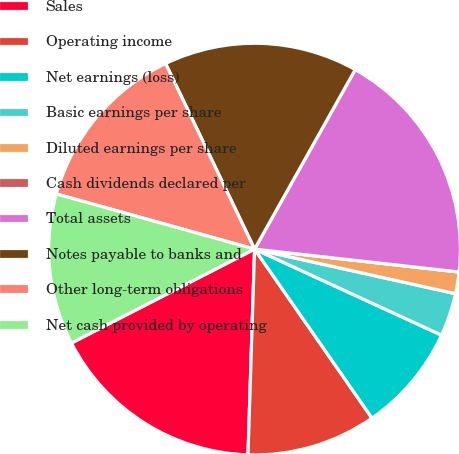<chart> <loc_0><loc_0><loc_500><loc_500><pie_chart><fcel>Sales<fcel>Operating income<fcel>Net earnings (loss)<fcel>Basic earnings per share<fcel>Diluted earnings per share<fcel>Cash dividends declared per<fcel>Total assets<fcel>Notes payable to banks and<fcel>Other long-term obligations<fcel>Net cash provided by operating<nl><fcel>16.95%<fcel>10.17%<fcel>8.47%<fcel>3.39%<fcel>1.7%<fcel>0.0%<fcel>18.64%<fcel>15.25%<fcel>13.56%<fcel>11.86%<nl></chart> 